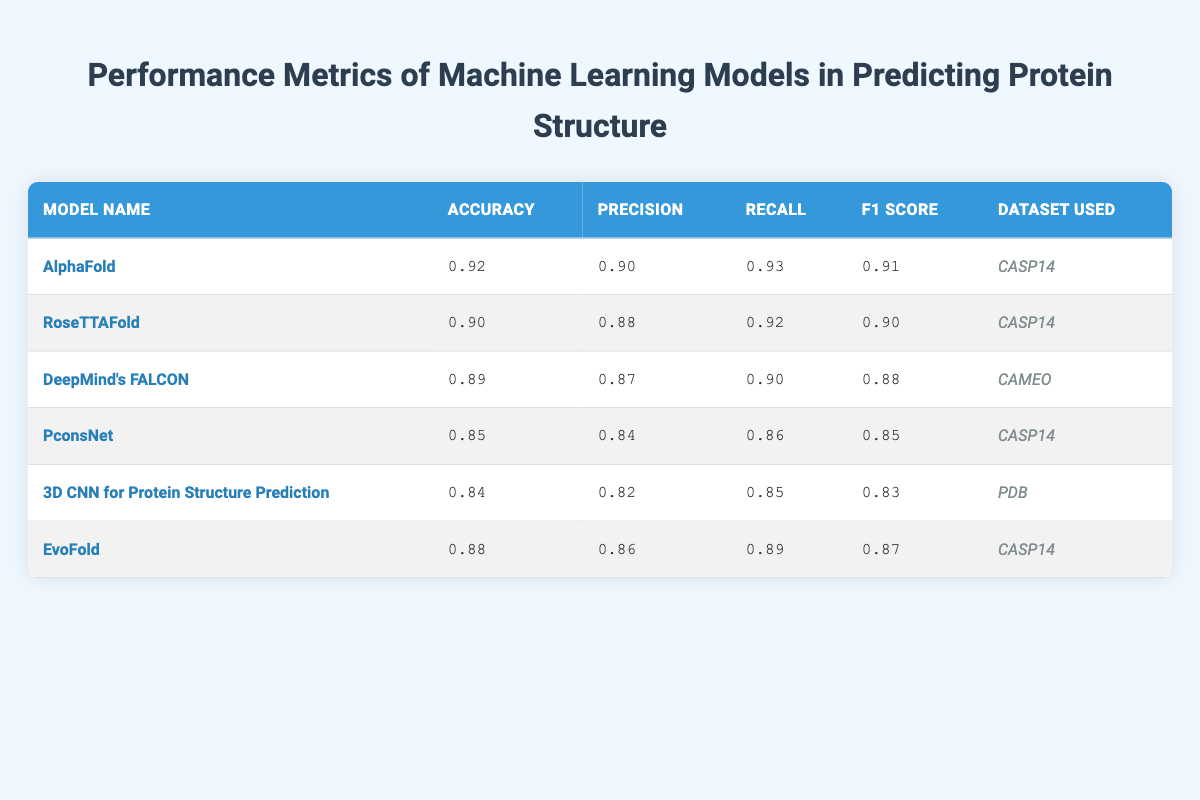What is the accuracy of AlphaFold? The accuracy for AlphaFold is listed in the table under the "Accuracy" column, specifically for the model name "AlphaFold." It shows a value of 0.92.
Answer: 0.92 Which model has the highest precision? To find the highest precision, we look at the "Precision" column across all models. AlphaFold has a precision of 0.90, while RoseTTAFold has 0.88, DeepMind's FALCON has 0.87, PconsNet has 0.84, 3D CNN has 0.82, and EvoFold has 0.86. Thus, AlphaFold has the highest precision.
Answer: AlphaFold Is the recall of EvoFold greater than 0.85? The recall value for EvoFold is 0.89, which is greater than 0.85. We compare 0.89 to 0.85 and confirm that it is indeed larger.
Answer: Yes What is the F1 score for the model trained on the CAMEO dataset? The model trained on the CAMEO dataset is DeepMind's FALCON. Looking at the "F1 Score" column for this model shows a value of 0.88.
Answer: 0.88 What is the difference in accuracy between AlphaFold and PconsNet? AlphaFold's accuracy is 0.92 while PconsNet's accuracy is 0.85. To find the difference, we subtract PconsNet's accuracy from AlphaFold's: 0.92 - 0.85 = 0.07.
Answer: 0.07 What is the average recall for the models listed? We take the recall values for all six models: 0.93 (AlphaFold), 0.92 (RoseTTAFold), 0.90 (DeepMind's FALCON), 0.86 (PconsNet), 0.85 (3D CNN), and 0.89 (EvoFold). Adding them: 0.93 + 0.92 + 0.90 + 0.86 + 0.85 + 0.89 = 5.25. Dividing by 6 gives us an average of 5.25/6, which is approximately 0.875.
Answer: 0.875 Does the model with the lowest F1 score also have the lowest precision? The model with the lowest F1 score is 3D CNN, which has a score of 0.83, and its precision is 0.82. The next lowest, PconsNet, has an F1 score of 0.85 and a precision of 0.84. Since 3D CNN indeed has the lowest values in both metrics, the answer is yes.
Answer: Yes Which dataset was used for the model with the highest accuracy? The model with the highest accuracy is AlphaFold, which is associated with the CASP14 dataset as listed in the table under the "Dataset Used" column next to AlphaFold.
Answer: CASP14 What are the metrics (accuracy, precision, recall) for RoseTTAFold? For RoseTTAFold, the metrics are: Accuracy 0.90, Precision 0.88, and Recall 0.92. These values can be found directly in the corresponding row under the relevant columns in the table.
Answer: 0.90, 0.88, 0.92 